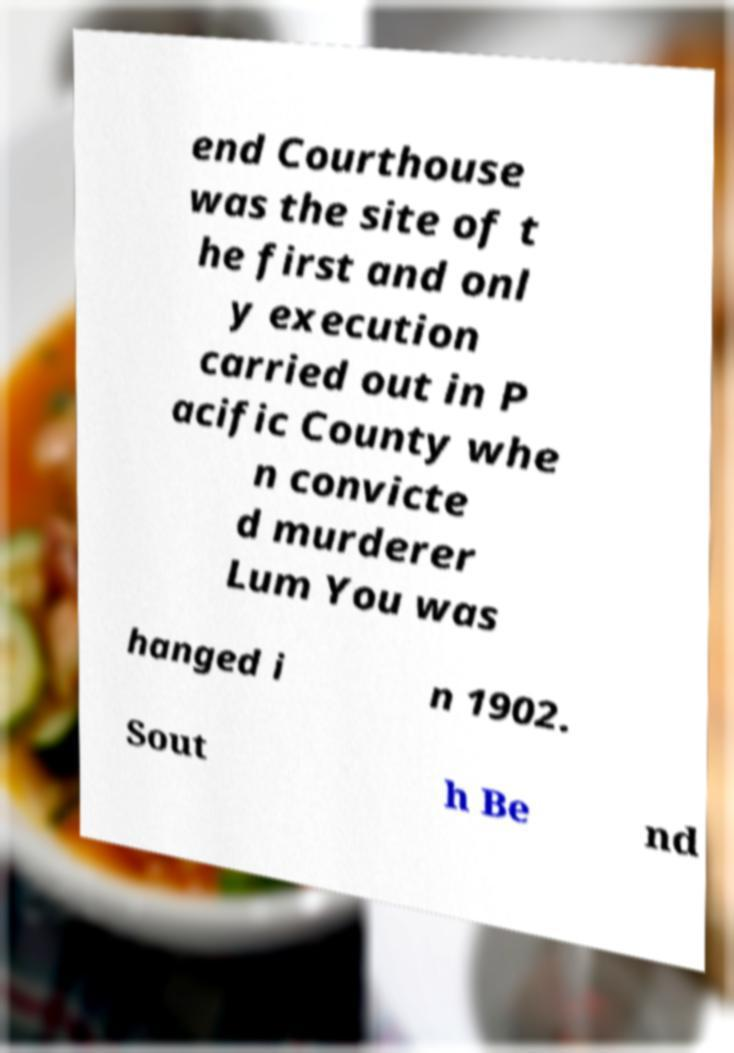Can you accurately transcribe the text from the provided image for me? end Courthouse was the site of t he first and onl y execution carried out in P acific County whe n convicte d murderer Lum You was hanged i n 1902. Sout h Be nd 